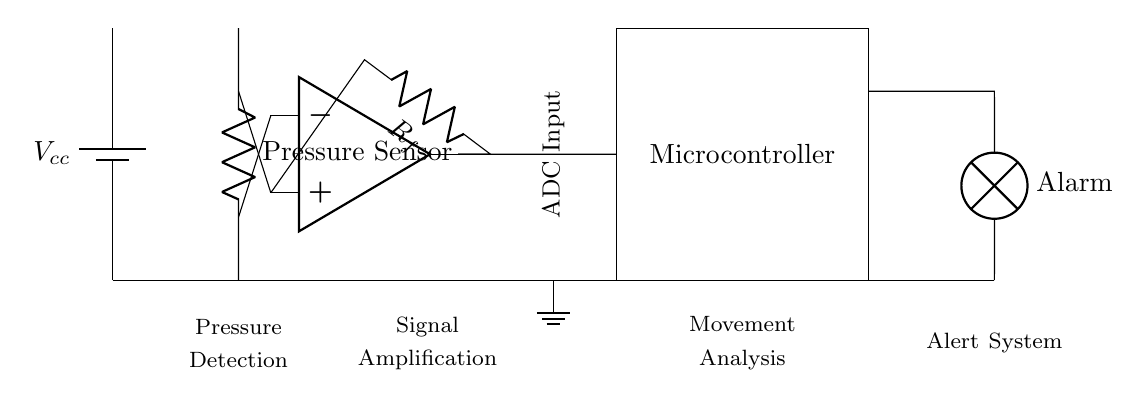What type of sensor is used in this circuit? The circuit includes a pressure sensor, as indicated by the label next to its symbol.
Answer: Pressure Sensor Where does the alarm output connect? The alarm output connects to a lamp, which is indicated by the label next to the lamp symbol in the circuit.
Answer: Lamp How many main components are in the circuit? The circuit features four main components: the battery, pressure sensor, op-amp, and microcontroller, which are distinctly labeled.
Answer: Four What is the role of the op-amp in this circuit? The op-amp serves as a signal amplifier, as evidenced by the label next to its symbol and its placement within the circuit between the pressure sensor and the microcontroller.
Answer: Signal Amplification What is the purpose of the feedback resistor? The feedback resistor helps maintain stability and control the gain of the op-amp to ensure proper amplification of the sensor signal, as inferred from its connection between the op-amp output and input.
Answer: Stabilize Gain At what stage is the movement analyzed? Movement is analyzed in the microcontroller stage, which follows the amplification process and receives the signal from the op-amp.
Answer: Movement Analysis 